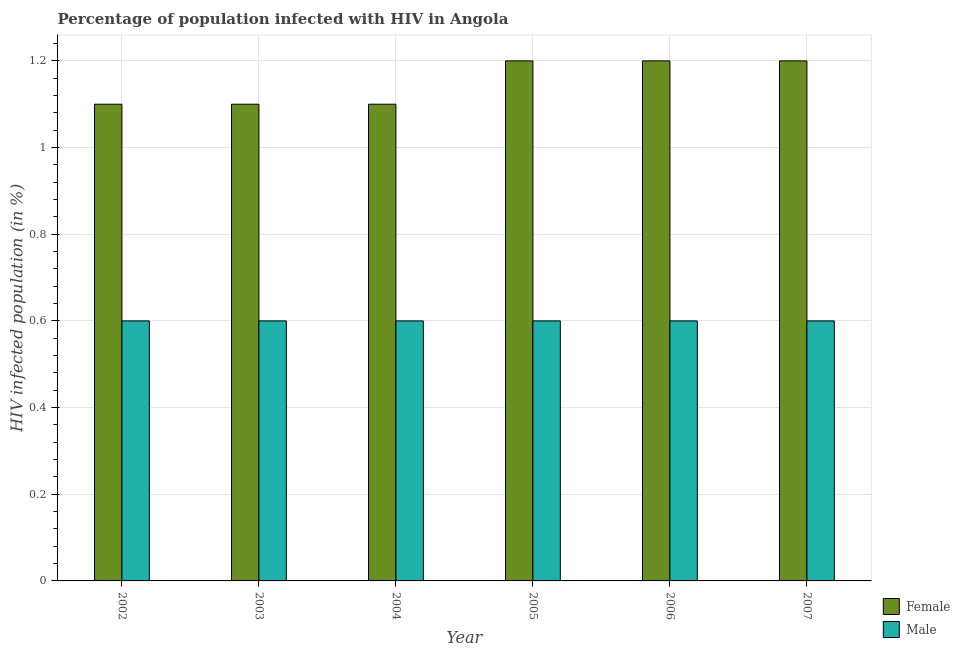How many different coloured bars are there?
Give a very brief answer. 2. How many groups of bars are there?
Make the answer very short. 6. Are the number of bars on each tick of the X-axis equal?
Give a very brief answer. Yes. How many bars are there on the 4th tick from the left?
Provide a short and direct response. 2. What is the percentage of males who are infected with hiv in 2006?
Make the answer very short. 0.6. Across all years, what is the maximum percentage of females who are infected with hiv?
Make the answer very short. 1.2. In which year was the percentage of males who are infected with hiv maximum?
Make the answer very short. 2002. What is the difference between the percentage of females who are infected with hiv in 2003 and that in 2007?
Offer a very short reply. -0.1. What is the average percentage of females who are infected with hiv per year?
Offer a terse response. 1.15. In the year 2005, what is the difference between the percentage of females who are infected with hiv and percentage of males who are infected with hiv?
Offer a very short reply. 0. In how many years, is the percentage of females who are infected with hiv greater than 0.4 %?
Ensure brevity in your answer.  6. What is the ratio of the percentage of males who are infected with hiv in 2002 to that in 2003?
Offer a very short reply. 1. Is the difference between the percentage of females who are infected with hiv in 2005 and 2006 greater than the difference between the percentage of males who are infected with hiv in 2005 and 2006?
Offer a very short reply. No. What is the difference between the highest and the second highest percentage of males who are infected with hiv?
Provide a succinct answer. 0. What is the difference between the highest and the lowest percentage of females who are infected with hiv?
Make the answer very short. 0.1. Is the sum of the percentage of males who are infected with hiv in 2003 and 2004 greater than the maximum percentage of females who are infected with hiv across all years?
Your answer should be compact. Yes. What does the 2nd bar from the left in 2007 represents?
Provide a succinct answer. Male. What does the 2nd bar from the right in 2002 represents?
Your answer should be very brief. Female. What is the difference between two consecutive major ticks on the Y-axis?
Ensure brevity in your answer.  0.2. Are the values on the major ticks of Y-axis written in scientific E-notation?
Your response must be concise. No. How many legend labels are there?
Your answer should be very brief. 2. What is the title of the graph?
Keep it short and to the point. Percentage of population infected with HIV in Angola. Does "Merchandise imports" appear as one of the legend labels in the graph?
Provide a short and direct response. No. What is the label or title of the X-axis?
Your response must be concise. Year. What is the label or title of the Y-axis?
Offer a very short reply. HIV infected population (in %). What is the HIV infected population (in %) in Female in 2002?
Make the answer very short. 1.1. What is the HIV infected population (in %) in Male in 2002?
Offer a terse response. 0.6. What is the HIV infected population (in %) of Female in 2003?
Offer a very short reply. 1.1. What is the HIV infected population (in %) in Female in 2004?
Offer a terse response. 1.1. What is the HIV infected population (in %) in Male in 2006?
Offer a very short reply. 0.6. What is the HIV infected population (in %) in Male in 2007?
Your answer should be compact. 0.6. Across all years, what is the maximum HIV infected population (in %) of Male?
Make the answer very short. 0.6. Across all years, what is the minimum HIV infected population (in %) in Male?
Your answer should be compact. 0.6. What is the total HIV infected population (in %) of Female in the graph?
Ensure brevity in your answer.  6.9. What is the difference between the HIV infected population (in %) in Female in 2002 and that in 2003?
Provide a succinct answer. 0. What is the difference between the HIV infected population (in %) in Male in 2002 and that in 2003?
Keep it short and to the point. 0. What is the difference between the HIV infected population (in %) in Female in 2002 and that in 2004?
Give a very brief answer. 0. What is the difference between the HIV infected population (in %) of Male in 2002 and that in 2004?
Your response must be concise. 0. What is the difference between the HIV infected population (in %) of Male in 2002 and that in 2005?
Make the answer very short. 0. What is the difference between the HIV infected population (in %) in Female in 2002 and that in 2006?
Give a very brief answer. -0.1. What is the difference between the HIV infected population (in %) of Female in 2003 and that in 2005?
Give a very brief answer. -0.1. What is the difference between the HIV infected population (in %) in Female in 2003 and that in 2006?
Offer a terse response. -0.1. What is the difference between the HIV infected population (in %) in Female in 2003 and that in 2007?
Your response must be concise. -0.1. What is the difference between the HIV infected population (in %) of Male in 2004 and that in 2005?
Make the answer very short. 0. What is the difference between the HIV infected population (in %) of Female in 2004 and that in 2006?
Offer a very short reply. -0.1. What is the difference between the HIV infected population (in %) of Male in 2004 and that in 2006?
Your response must be concise. 0. What is the difference between the HIV infected population (in %) of Male in 2004 and that in 2007?
Ensure brevity in your answer.  0. What is the difference between the HIV infected population (in %) in Male in 2005 and that in 2006?
Ensure brevity in your answer.  0. What is the difference between the HIV infected population (in %) of Female in 2005 and that in 2007?
Make the answer very short. 0. What is the difference between the HIV infected population (in %) in Male in 2005 and that in 2007?
Provide a short and direct response. 0. What is the difference between the HIV infected population (in %) in Female in 2002 and the HIV infected population (in %) in Male in 2003?
Offer a terse response. 0.5. What is the difference between the HIV infected population (in %) of Female in 2002 and the HIV infected population (in %) of Male in 2005?
Provide a short and direct response. 0.5. What is the difference between the HIV infected population (in %) in Female in 2002 and the HIV infected population (in %) in Male in 2006?
Your answer should be compact. 0.5. What is the difference between the HIV infected population (in %) in Female in 2002 and the HIV infected population (in %) in Male in 2007?
Ensure brevity in your answer.  0.5. What is the difference between the HIV infected population (in %) in Female in 2003 and the HIV infected population (in %) in Male in 2005?
Keep it short and to the point. 0.5. What is the difference between the HIV infected population (in %) of Female in 2003 and the HIV infected population (in %) of Male in 2006?
Ensure brevity in your answer.  0.5. What is the difference between the HIV infected population (in %) in Female in 2004 and the HIV infected population (in %) in Male in 2006?
Keep it short and to the point. 0.5. What is the difference between the HIV infected population (in %) of Female in 2004 and the HIV infected population (in %) of Male in 2007?
Provide a short and direct response. 0.5. What is the difference between the HIV infected population (in %) of Female in 2005 and the HIV infected population (in %) of Male in 2006?
Give a very brief answer. 0.6. What is the average HIV infected population (in %) of Female per year?
Your answer should be very brief. 1.15. What is the average HIV infected population (in %) of Male per year?
Make the answer very short. 0.6. In the year 2003, what is the difference between the HIV infected population (in %) in Female and HIV infected population (in %) in Male?
Make the answer very short. 0.5. In the year 2004, what is the difference between the HIV infected population (in %) of Female and HIV infected population (in %) of Male?
Offer a terse response. 0.5. In the year 2005, what is the difference between the HIV infected population (in %) in Female and HIV infected population (in %) in Male?
Make the answer very short. 0.6. In the year 2007, what is the difference between the HIV infected population (in %) in Female and HIV infected population (in %) in Male?
Give a very brief answer. 0.6. What is the ratio of the HIV infected population (in %) in Female in 2002 to that in 2003?
Offer a terse response. 1. What is the ratio of the HIV infected population (in %) in Male in 2002 to that in 2003?
Ensure brevity in your answer.  1. What is the ratio of the HIV infected population (in %) in Female in 2002 to that in 2004?
Ensure brevity in your answer.  1. What is the ratio of the HIV infected population (in %) in Female in 2003 to that in 2004?
Your response must be concise. 1. What is the ratio of the HIV infected population (in %) of Female in 2003 to that in 2005?
Ensure brevity in your answer.  0.92. What is the ratio of the HIV infected population (in %) in Male in 2003 to that in 2005?
Keep it short and to the point. 1. What is the ratio of the HIV infected population (in %) of Female in 2003 to that in 2006?
Make the answer very short. 0.92. What is the ratio of the HIV infected population (in %) of Female in 2003 to that in 2007?
Provide a short and direct response. 0.92. What is the ratio of the HIV infected population (in %) in Male in 2003 to that in 2007?
Offer a terse response. 1. What is the ratio of the HIV infected population (in %) of Female in 2004 to that in 2005?
Your answer should be very brief. 0.92. What is the ratio of the HIV infected population (in %) in Male in 2004 to that in 2005?
Keep it short and to the point. 1. What is the ratio of the HIV infected population (in %) of Male in 2004 to that in 2006?
Give a very brief answer. 1. What is the ratio of the HIV infected population (in %) in Female in 2004 to that in 2007?
Your answer should be compact. 0.92. What is the ratio of the HIV infected population (in %) in Male in 2004 to that in 2007?
Give a very brief answer. 1. What is the ratio of the HIV infected population (in %) of Female in 2005 to that in 2006?
Ensure brevity in your answer.  1. What is the ratio of the HIV infected population (in %) in Male in 2005 to that in 2006?
Ensure brevity in your answer.  1. What is the ratio of the HIV infected population (in %) of Female in 2006 to that in 2007?
Keep it short and to the point. 1. What is the ratio of the HIV infected population (in %) of Male in 2006 to that in 2007?
Provide a succinct answer. 1. What is the difference between the highest and the second highest HIV infected population (in %) of Male?
Your answer should be very brief. 0. 